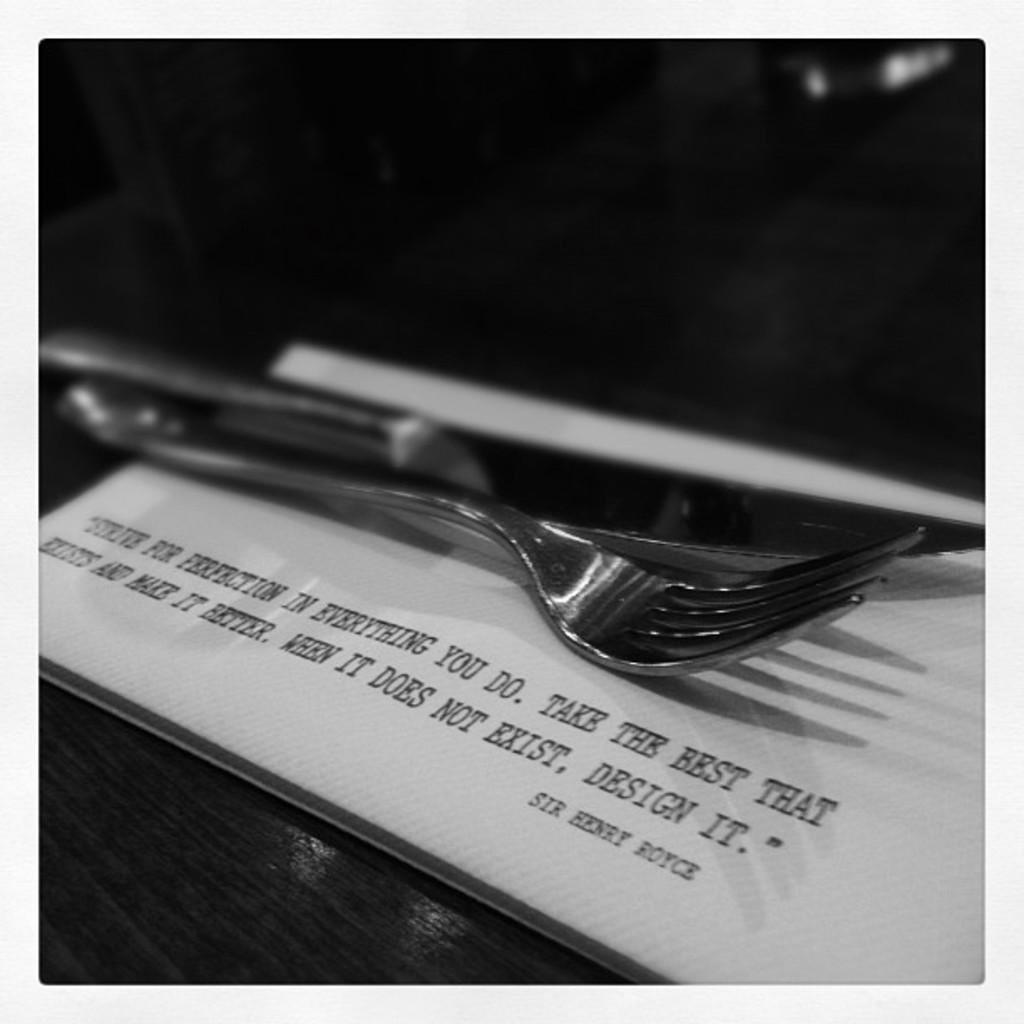What object is located in the center of the image? There is a fork in the center of the image. Where is the fork placed? The fork is on a table. What else can be seen on the table? There is a book on the table. Can you describe the book? There is text written on the book. How does the kite help the person eat the food in the image? There is no kite present in the image, so it cannot help the person eat the food. 